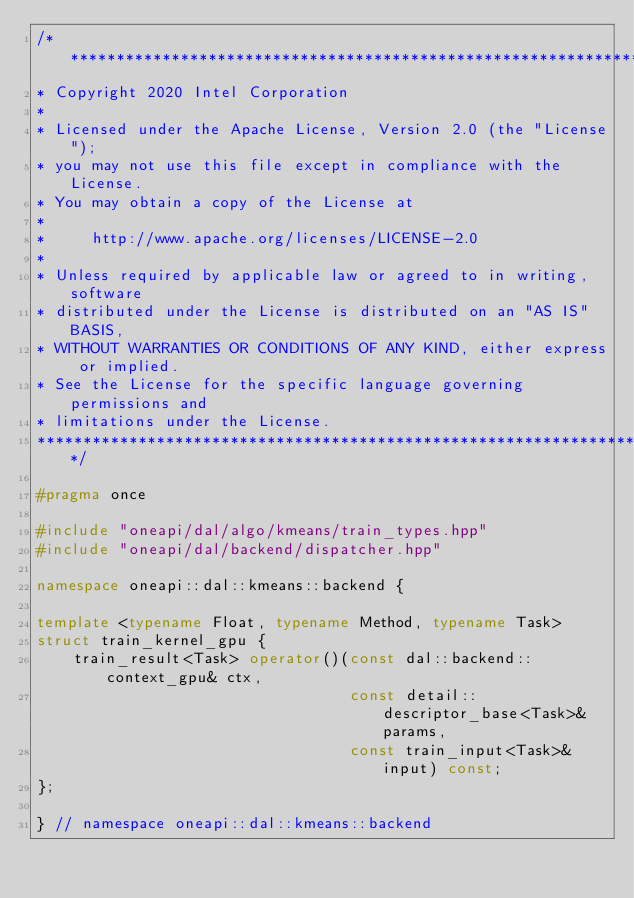<code> <loc_0><loc_0><loc_500><loc_500><_C++_>/*******************************************************************************
* Copyright 2020 Intel Corporation
*
* Licensed under the Apache License, Version 2.0 (the "License");
* you may not use this file except in compliance with the License.
* You may obtain a copy of the License at
*
*     http://www.apache.org/licenses/LICENSE-2.0
*
* Unless required by applicable law or agreed to in writing, software
* distributed under the License is distributed on an "AS IS" BASIS,
* WITHOUT WARRANTIES OR CONDITIONS OF ANY KIND, either express or implied.
* See the License for the specific language governing permissions and
* limitations under the License.
*******************************************************************************/

#pragma once

#include "oneapi/dal/algo/kmeans/train_types.hpp"
#include "oneapi/dal/backend/dispatcher.hpp"

namespace oneapi::dal::kmeans::backend {

template <typename Float, typename Method, typename Task>
struct train_kernel_gpu {
    train_result<Task> operator()(const dal::backend::context_gpu& ctx,
                                  const detail::descriptor_base<Task>& params,
                                  const train_input<Task>& input) const;
};

} // namespace oneapi::dal::kmeans::backend
</code> 